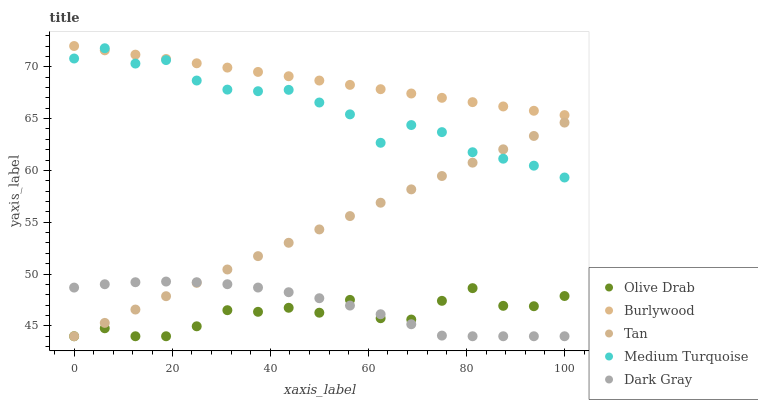Does Olive Drab have the minimum area under the curve?
Answer yes or no. Yes. Does Burlywood have the maximum area under the curve?
Answer yes or no. Yes. Does Dark Gray have the minimum area under the curve?
Answer yes or no. No. Does Dark Gray have the maximum area under the curve?
Answer yes or no. No. Is Tan the smoothest?
Answer yes or no. Yes. Is Medium Turquoise the roughest?
Answer yes or no. Yes. Is Dark Gray the smoothest?
Answer yes or no. No. Is Dark Gray the roughest?
Answer yes or no. No. Does Dark Gray have the lowest value?
Answer yes or no. Yes. Does Medium Turquoise have the lowest value?
Answer yes or no. No. Does Burlywood have the highest value?
Answer yes or no. Yes. Does Dark Gray have the highest value?
Answer yes or no. No. Is Olive Drab less than Medium Turquoise?
Answer yes or no. Yes. Is Medium Turquoise greater than Dark Gray?
Answer yes or no. Yes. Does Tan intersect Olive Drab?
Answer yes or no. Yes. Is Tan less than Olive Drab?
Answer yes or no. No. Is Tan greater than Olive Drab?
Answer yes or no. No. Does Olive Drab intersect Medium Turquoise?
Answer yes or no. No. 